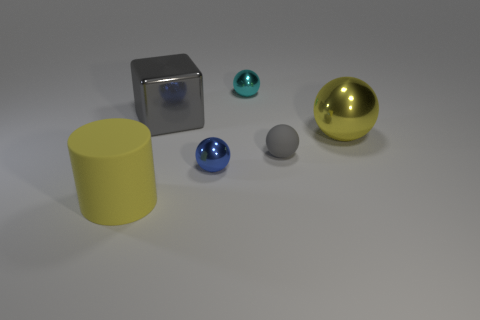Is there any other thing that has the same size as the gray matte object?
Offer a very short reply. Yes. There is a gray metallic block left of the blue object; does it have the same size as the rubber object that is on the right side of the large rubber thing?
Provide a succinct answer. No. Do the blue object and the big gray thing have the same shape?
Provide a succinct answer. No. How many things are either yellow things that are in front of the yellow ball or matte cylinders?
Your answer should be very brief. 1. Is there a blue shiny thing that has the same shape as the cyan metallic thing?
Your answer should be compact. Yes. Are there the same number of matte objects on the left side of the tiny blue sphere and brown things?
Provide a short and direct response. No. There is a big shiny object that is the same color as the matte sphere; what is its shape?
Your answer should be compact. Cube. What number of other blue metallic objects are the same size as the blue thing?
Provide a succinct answer. 0. There is a small cyan shiny thing; how many cyan things are in front of it?
Your answer should be very brief. 0. What material is the big yellow thing on the right side of the matte cylinder in front of the yellow metal sphere?
Offer a terse response. Metal. 